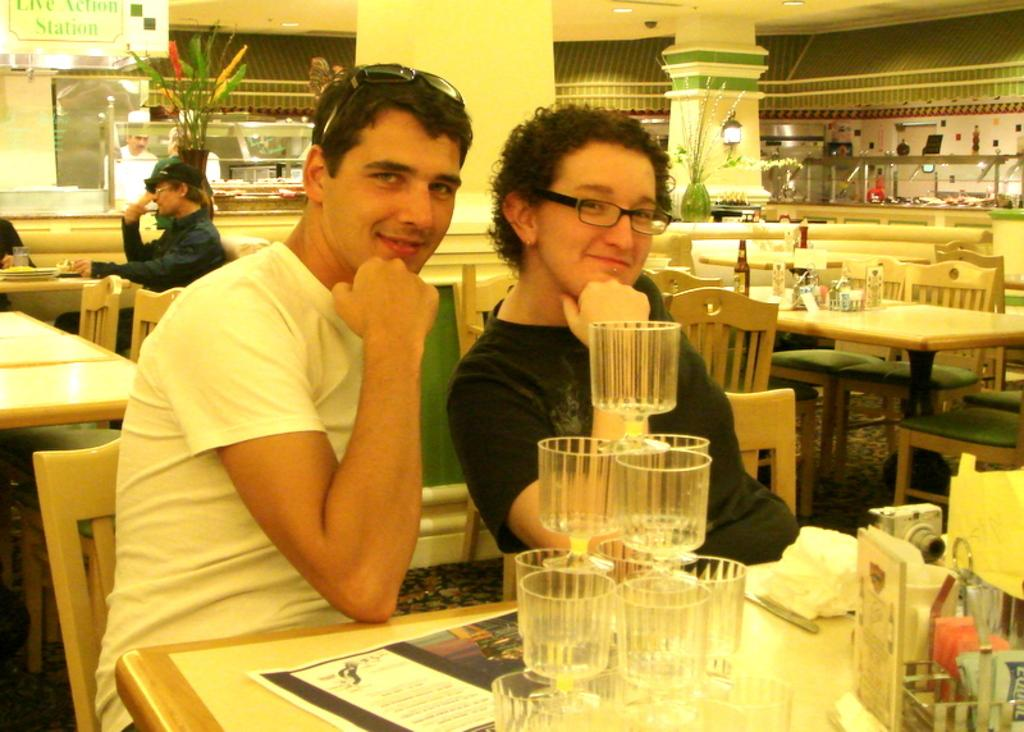What color is the wall in the image? There is a yellow wall in the image. What are the people in the image doing? The people are sitting on chairs in the image. What type of furniture is present in the image? There are tables in the image. What items can be seen on the tables? There are glasses, bottles, boxes, and plates on the tables. What type of scale can be seen in the image? There is no scale present in the image. What kind of experience can be felt by the people sitting on the chairs in the image? The image does not provide information about the feelings or experiences of the people sitting on the chairs. 